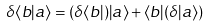<formula> <loc_0><loc_0><loc_500><loc_500>\delta \langle b | a \rangle = ( \delta \langle b | ) | a \rangle + \langle b | ( \delta | a \rangle )</formula> 